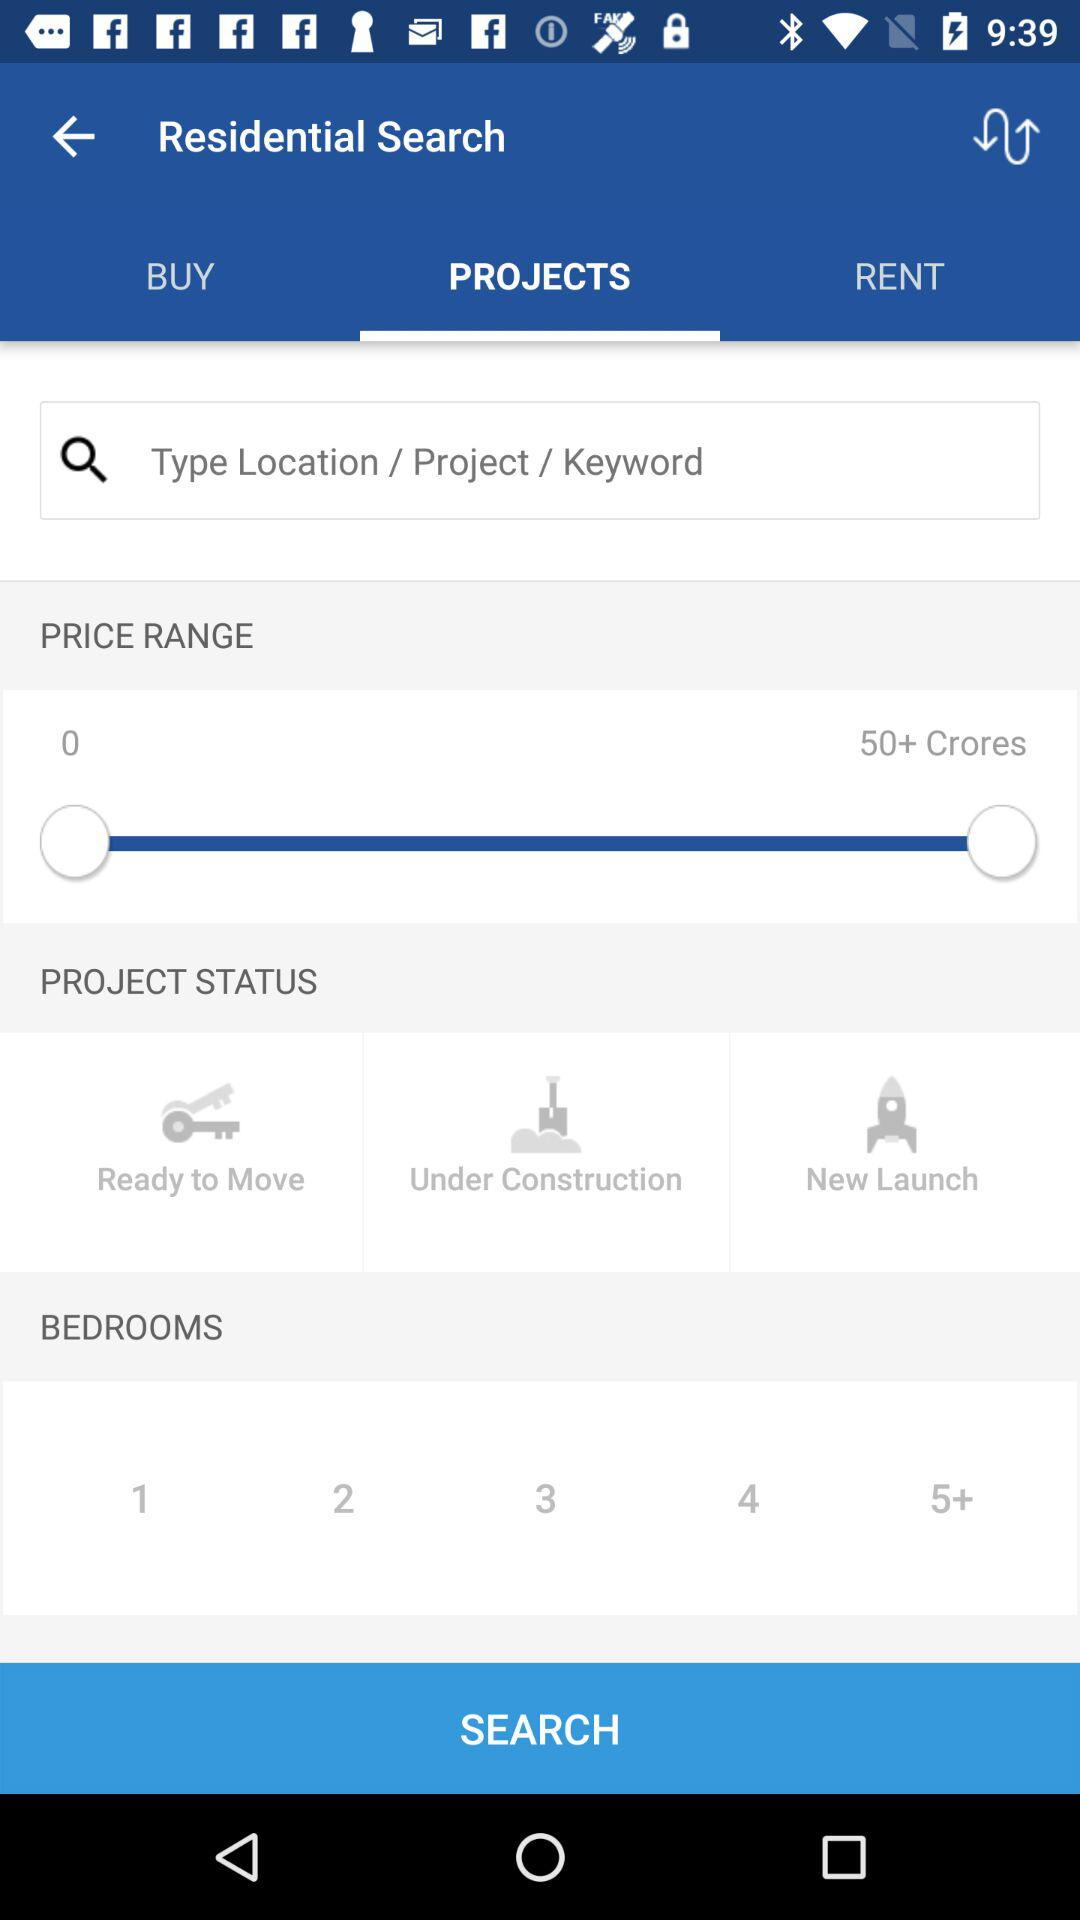What is the price range? The price range is between 0 and 50+ crores. 